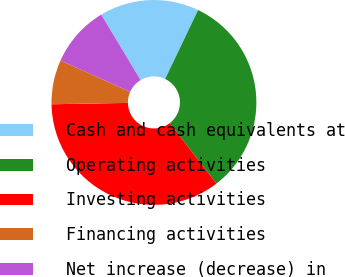Convert chart to OTSL. <chart><loc_0><loc_0><loc_500><loc_500><pie_chart><fcel>Cash and cash equivalents at<fcel>Operating activities<fcel>Investing activities<fcel>Financing activities<fcel>Net increase (decrease) in<nl><fcel>15.7%<fcel>32.46%<fcel>35.16%<fcel>6.99%<fcel>9.69%<nl></chart> 